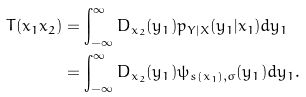<formula> <loc_0><loc_0><loc_500><loc_500>T ( x _ { 1 } x _ { 2 } ) & = \int _ { - \infty } ^ { \infty } D _ { x _ { 2 } } ( y _ { 1 } ) p _ { Y | X } ( y _ { 1 } | x _ { 1 } ) d y _ { 1 } \\ & = \int _ { - \infty } ^ { \infty } D _ { x _ { 2 } } ( y _ { 1 } ) \psi _ { s ( x _ { 1 } ) , \sigma } ( y _ { 1 } ) d y _ { 1 } .</formula> 